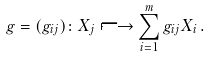<formula> <loc_0><loc_0><loc_500><loc_500>g = ( g _ { i j } ) \colon X _ { j } \longmapsto \sum _ { i = 1 } ^ { m } g _ { i j } X _ { i } \, .</formula> 